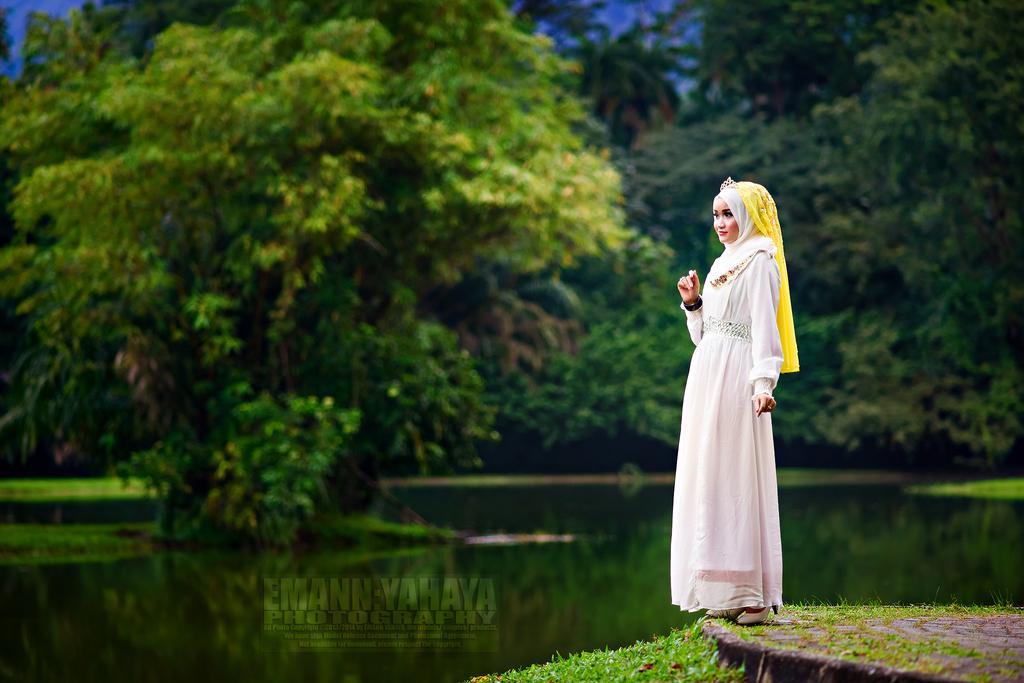Can you describe this image briefly? In this picture we can see a girl standing, at the bottom there is grass, we can see water in the middle, in the background there are some trees, there is some text at the bottom. 